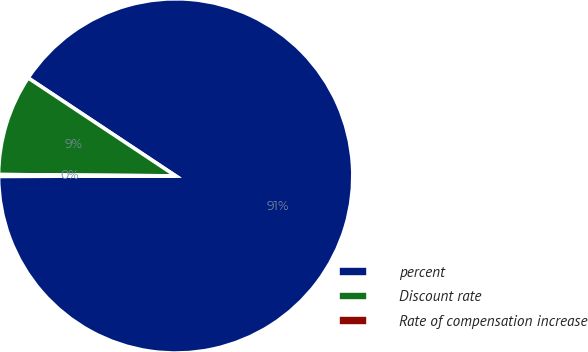<chart> <loc_0><loc_0><loc_500><loc_500><pie_chart><fcel>percent<fcel>Discount rate<fcel>Rate of compensation increase<nl><fcel>90.64%<fcel>9.21%<fcel>0.16%<nl></chart> 